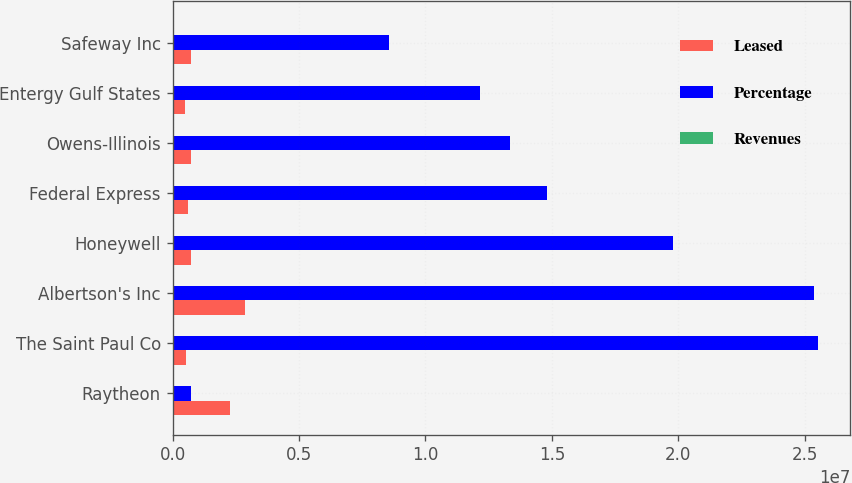Convert chart to OTSL. <chart><loc_0><loc_0><loc_500><loc_500><stacked_bar_chart><ecel><fcel>Raytheon<fcel>The Saint Paul Co<fcel>Albertson's Inc<fcel>Honeywell<fcel>Federal Express<fcel>Owens-Illinois<fcel>Entergy Gulf States<fcel>Safeway Inc<nl><fcel>Leased<fcel>2.286e+06<fcel>530000<fcel>2.843e+06<fcel>728000<fcel>592000<fcel>707000<fcel>489000<fcel>736000<nl><fcel>Percentage<fcel>707000<fcel>2.5532e+07<fcel>2.5378e+07<fcel>1.9799e+07<fcel>1.4812e+07<fcel>1.3363e+07<fcel>1.2147e+07<fcel>8.543e+06<nl><fcel>Revenues<fcel>16.3<fcel>10.3<fcel>10.3<fcel>8<fcel>6<fcel>5.4<fcel>4.9<fcel>3.5<nl></chart> 